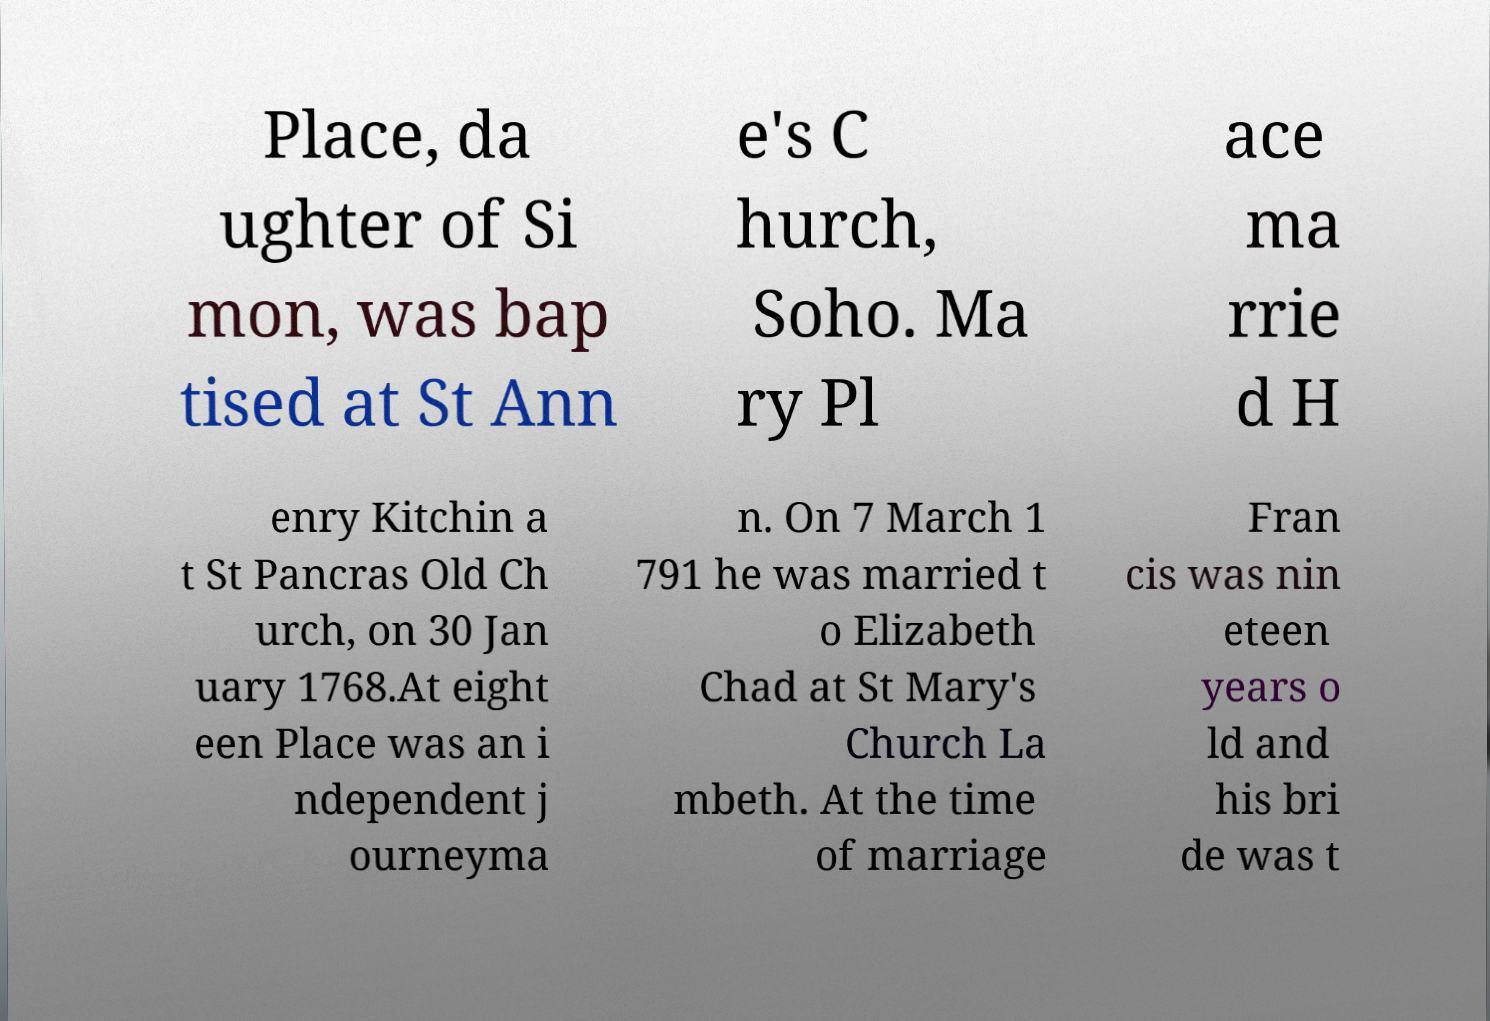Could you extract and type out the text from this image? Place, da ughter of Si mon, was bap tised at St Ann e's C hurch, Soho. Ma ry Pl ace ma rrie d H enry Kitchin a t St Pancras Old Ch urch, on 30 Jan uary 1768.At eight een Place was an i ndependent j ourneyma n. On 7 March 1 791 he was married t o Elizabeth Chad at St Mary's Church La mbeth. At the time of marriage Fran cis was nin eteen years o ld and his bri de was t 